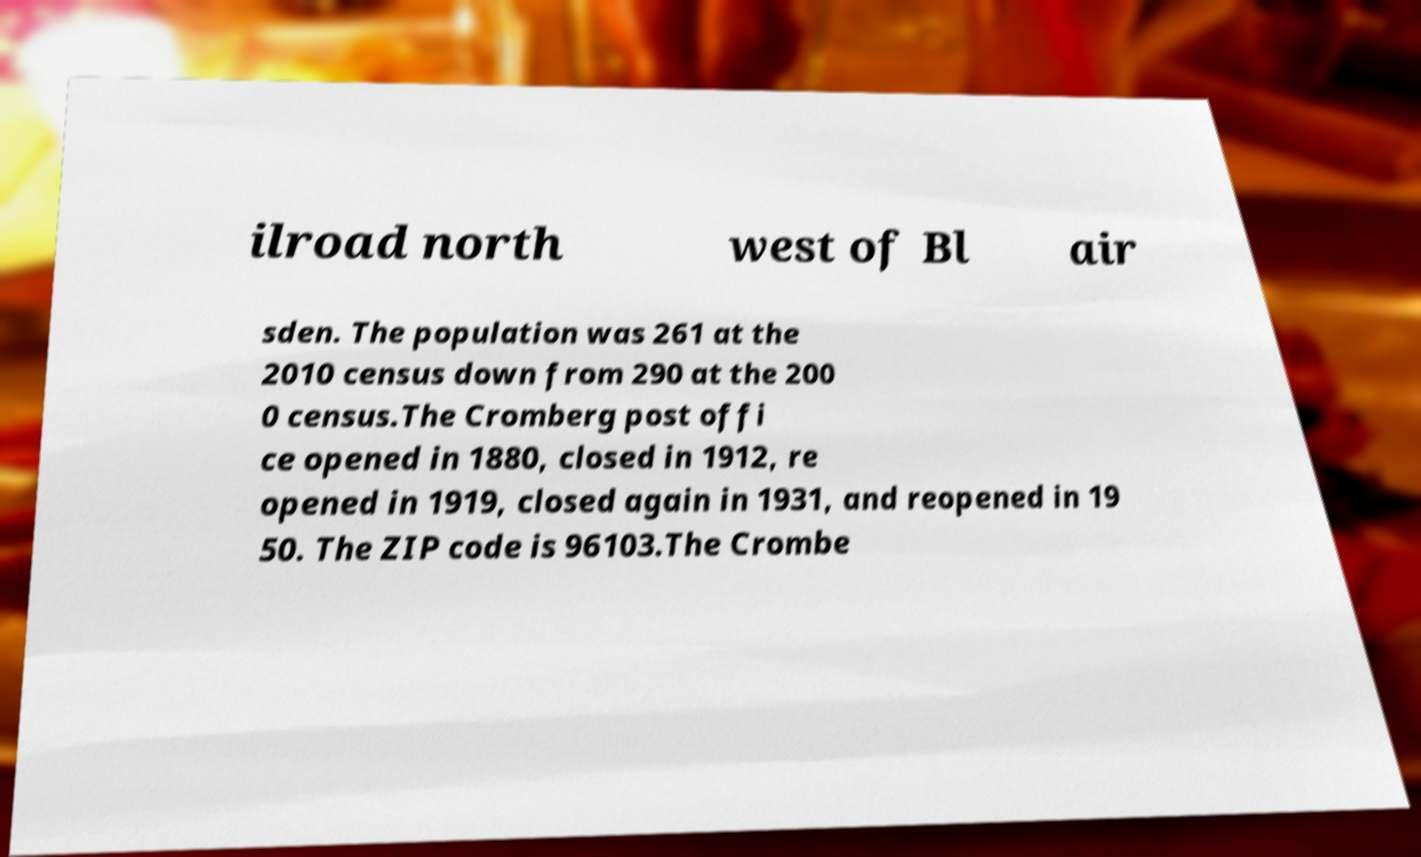I need the written content from this picture converted into text. Can you do that? ilroad north west of Bl air sden. The population was 261 at the 2010 census down from 290 at the 200 0 census.The Cromberg post offi ce opened in 1880, closed in 1912, re opened in 1919, closed again in 1931, and reopened in 19 50. The ZIP code is 96103.The Crombe 